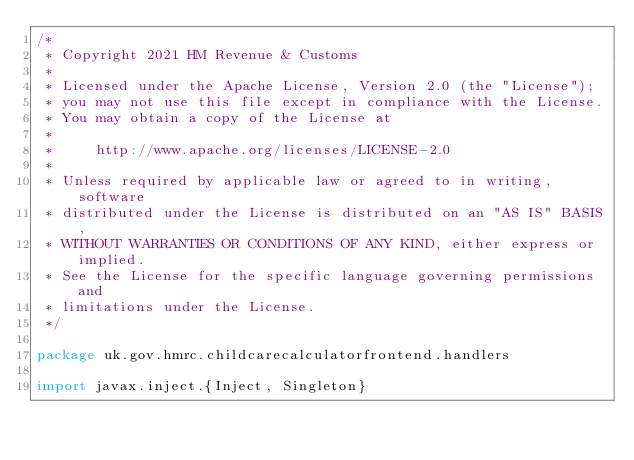<code> <loc_0><loc_0><loc_500><loc_500><_Scala_>/*
 * Copyright 2021 HM Revenue & Customs
 *
 * Licensed under the Apache License, Version 2.0 (the "License");
 * you may not use this file except in compliance with the License.
 * You may obtain a copy of the License at
 *
 *     http://www.apache.org/licenses/LICENSE-2.0
 *
 * Unless required by applicable law or agreed to in writing, software
 * distributed under the License is distributed on an "AS IS" BASIS,
 * WITHOUT WARRANTIES OR CONDITIONS OF ANY KIND, either express or implied.
 * See the License for the specific language governing permissions and
 * limitations under the License.
 */

package uk.gov.hmrc.childcarecalculatorfrontend.handlers

import javax.inject.{Inject, Singleton}</code> 